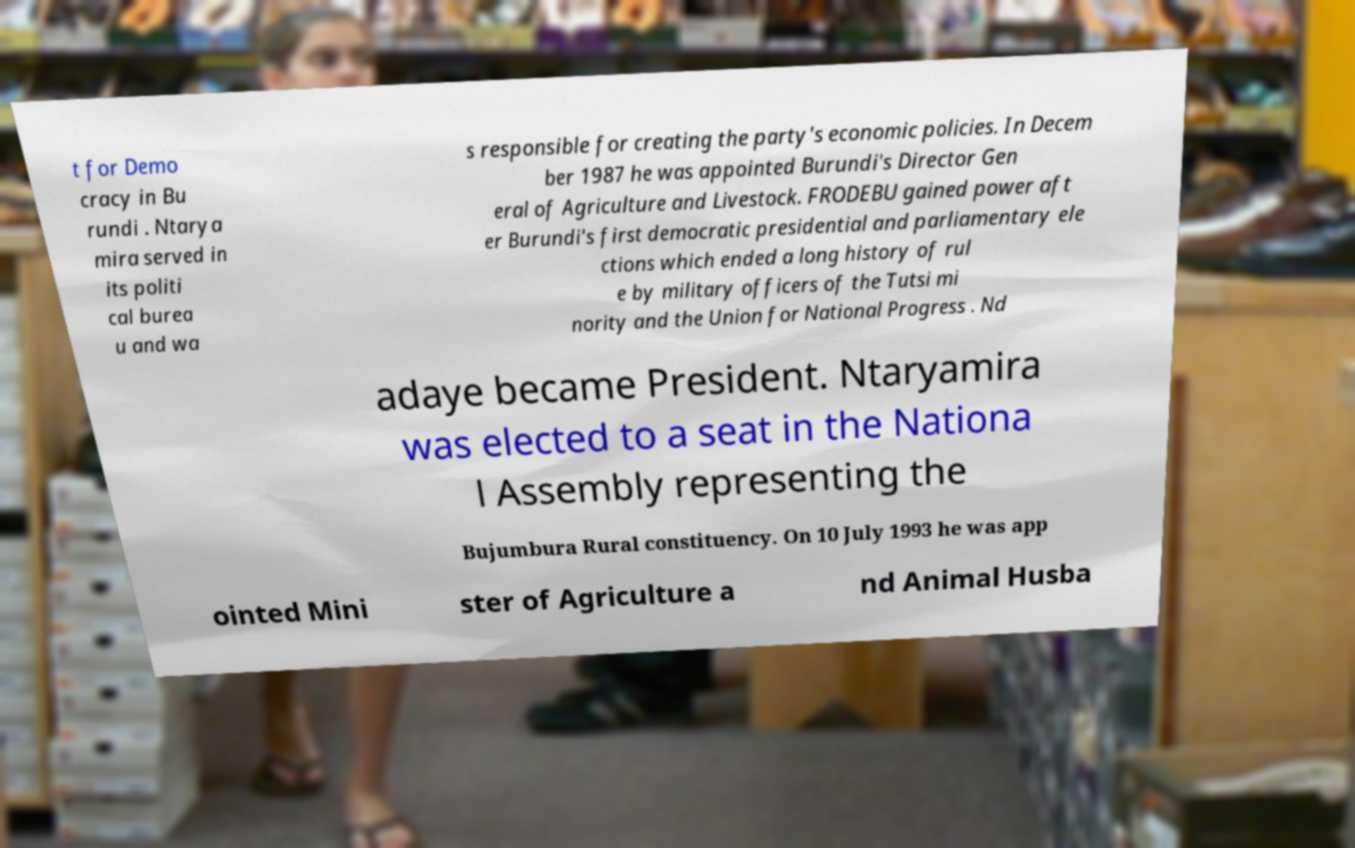For documentation purposes, I need the text within this image transcribed. Could you provide that? t for Demo cracy in Bu rundi . Ntarya mira served in its politi cal burea u and wa s responsible for creating the party's economic policies. In Decem ber 1987 he was appointed Burundi's Director Gen eral of Agriculture and Livestock. FRODEBU gained power aft er Burundi's first democratic presidential and parliamentary ele ctions which ended a long history of rul e by military officers of the Tutsi mi nority and the Union for National Progress . Nd adaye became President. Ntaryamira was elected to a seat in the Nationa l Assembly representing the Bujumbura Rural constituency. On 10 July 1993 he was app ointed Mini ster of Agriculture a nd Animal Husba 